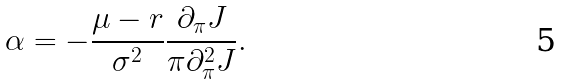Convert formula to latex. <formula><loc_0><loc_0><loc_500><loc_500>\alpha = - \frac { \mu - r } { \sigma ^ { 2 } } \frac { \partial _ { \pi } J } { \pi \partial _ { \pi } ^ { 2 } J } .</formula> 